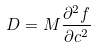Convert formula to latex. <formula><loc_0><loc_0><loc_500><loc_500>D = M \frac { \partial ^ { 2 } f } { \partial c ^ { 2 } }</formula> 